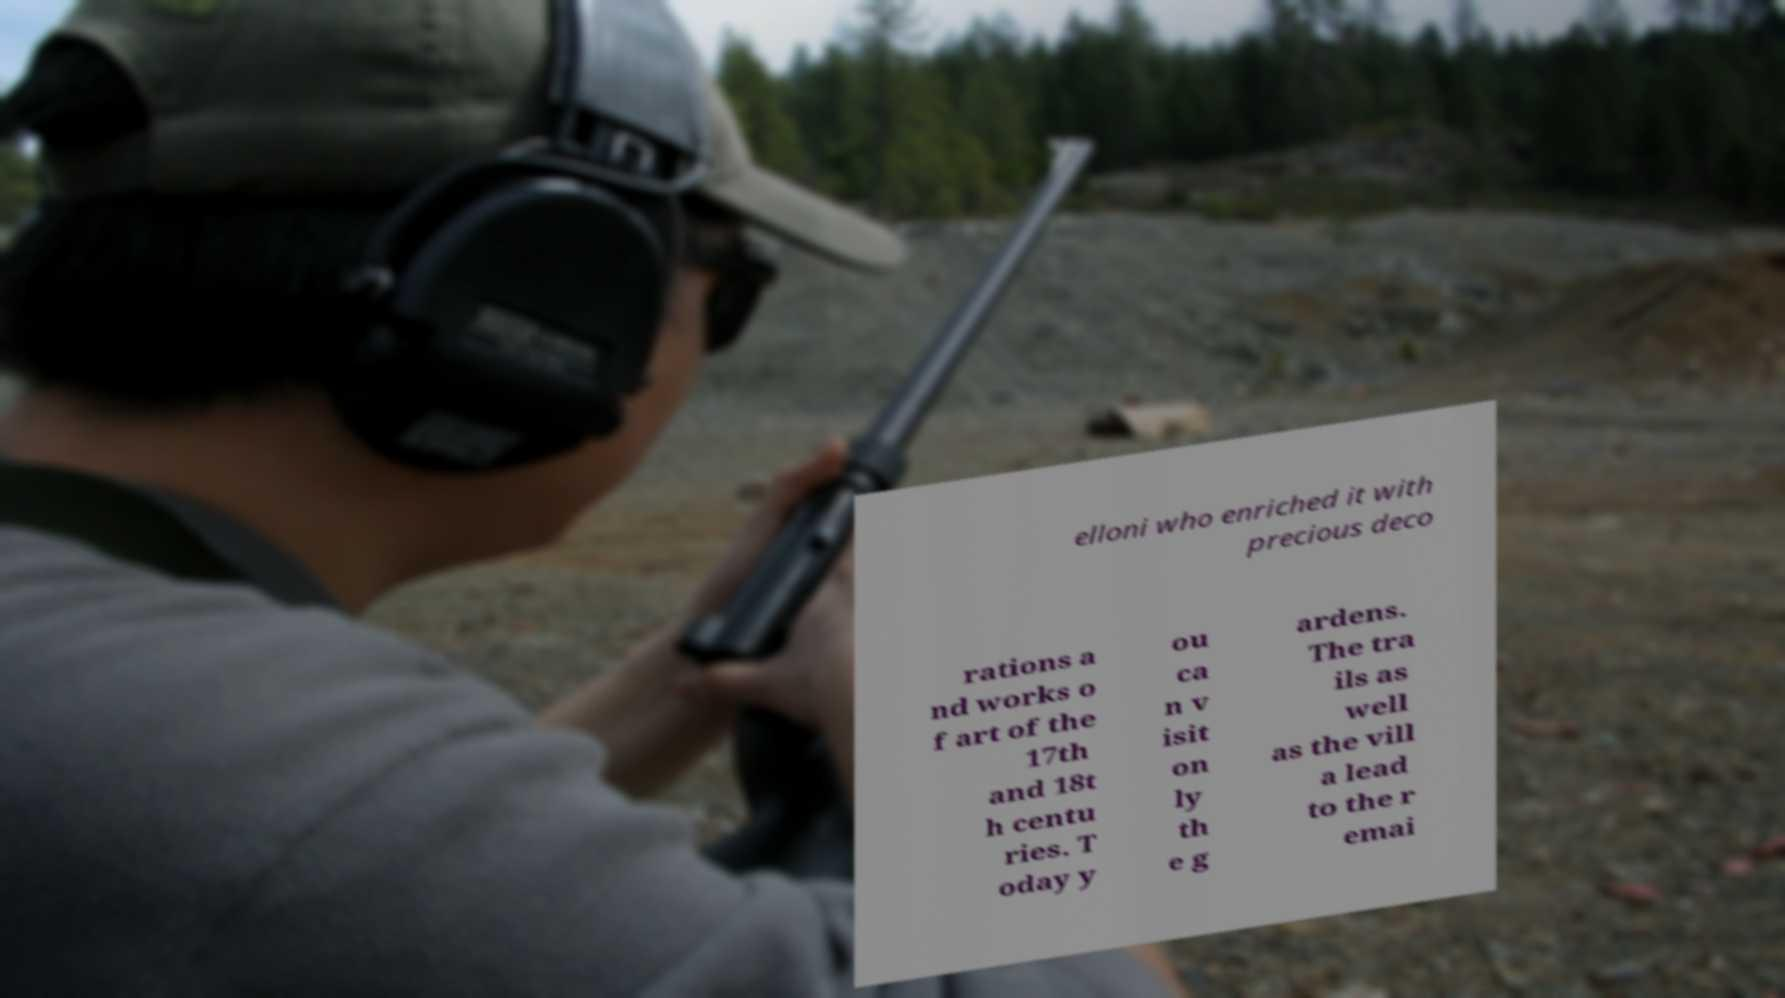For documentation purposes, I need the text within this image transcribed. Could you provide that? elloni who enriched it with precious deco rations a nd works o f art of the 17th and 18t h centu ries. T oday y ou ca n v isit on ly th e g ardens. The tra ils as well as the vill a lead to the r emai 